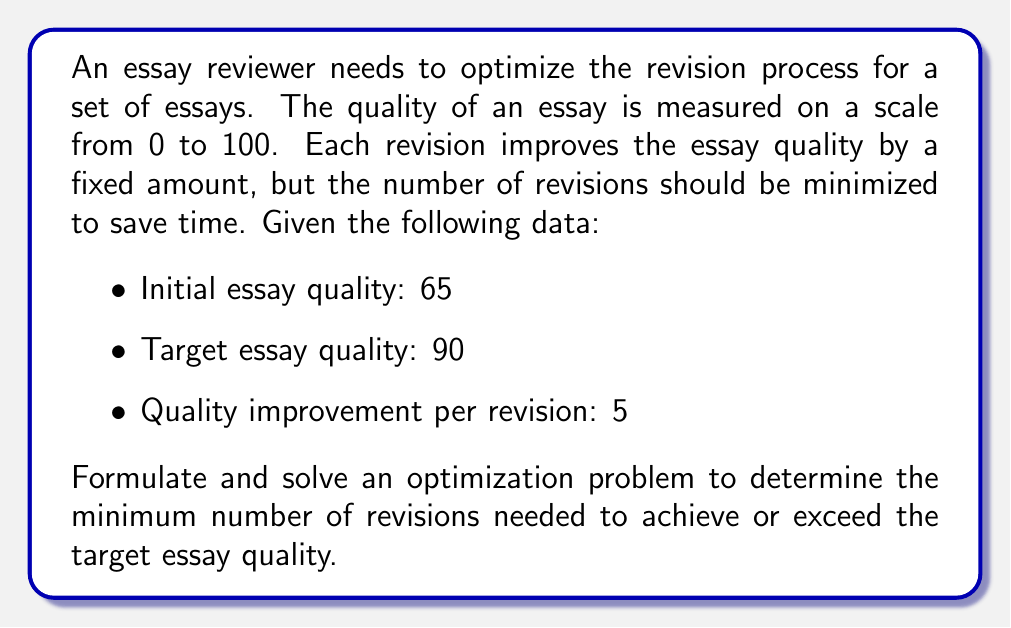Show me your answer to this math problem. To solve this optimization problem, we can follow these steps:

1. Define the decision variable:
   Let $x$ be the number of revisions.

2. Set up the objective function:
   We want to minimize the number of revisions, so our objective function is:
   $$\text{Minimize } f(x) = x$$

3. Determine the constraints:
   The essay quality after revisions must be greater than or equal to the target quality:
   $$65 + 5x \geq 90$$

4. Solve the inequality:
   $$5x \geq 25$$
   $$x \geq 5$$

5. Since $x$ represents the number of revisions, it must be a non-negative integer. Therefore, we need to round up to the nearest integer:
   $$x = \lceil 5 \rceil = 5$$

6. Verify the solution:
   Initial quality + (Quality improvement per revision × Number of revisions) = Final quality
   $$65 + (5 × 5) = 90$$

This confirms that 5 revisions will achieve the target essay quality of 90.
Answer: The minimum number of revisions needed to achieve or exceed the target essay quality is 5. 